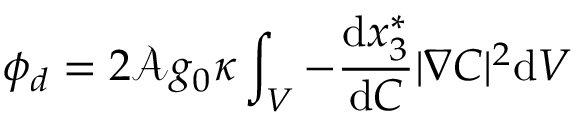<formula> <loc_0><loc_0><loc_500><loc_500>\phi _ { d } = 2 \mathcal { A } g _ { 0 } \kappa \int _ { V } - \frac { d x _ { 3 } ^ { * } } { d C } | \nabla C | ^ { 2 } d V</formula> 